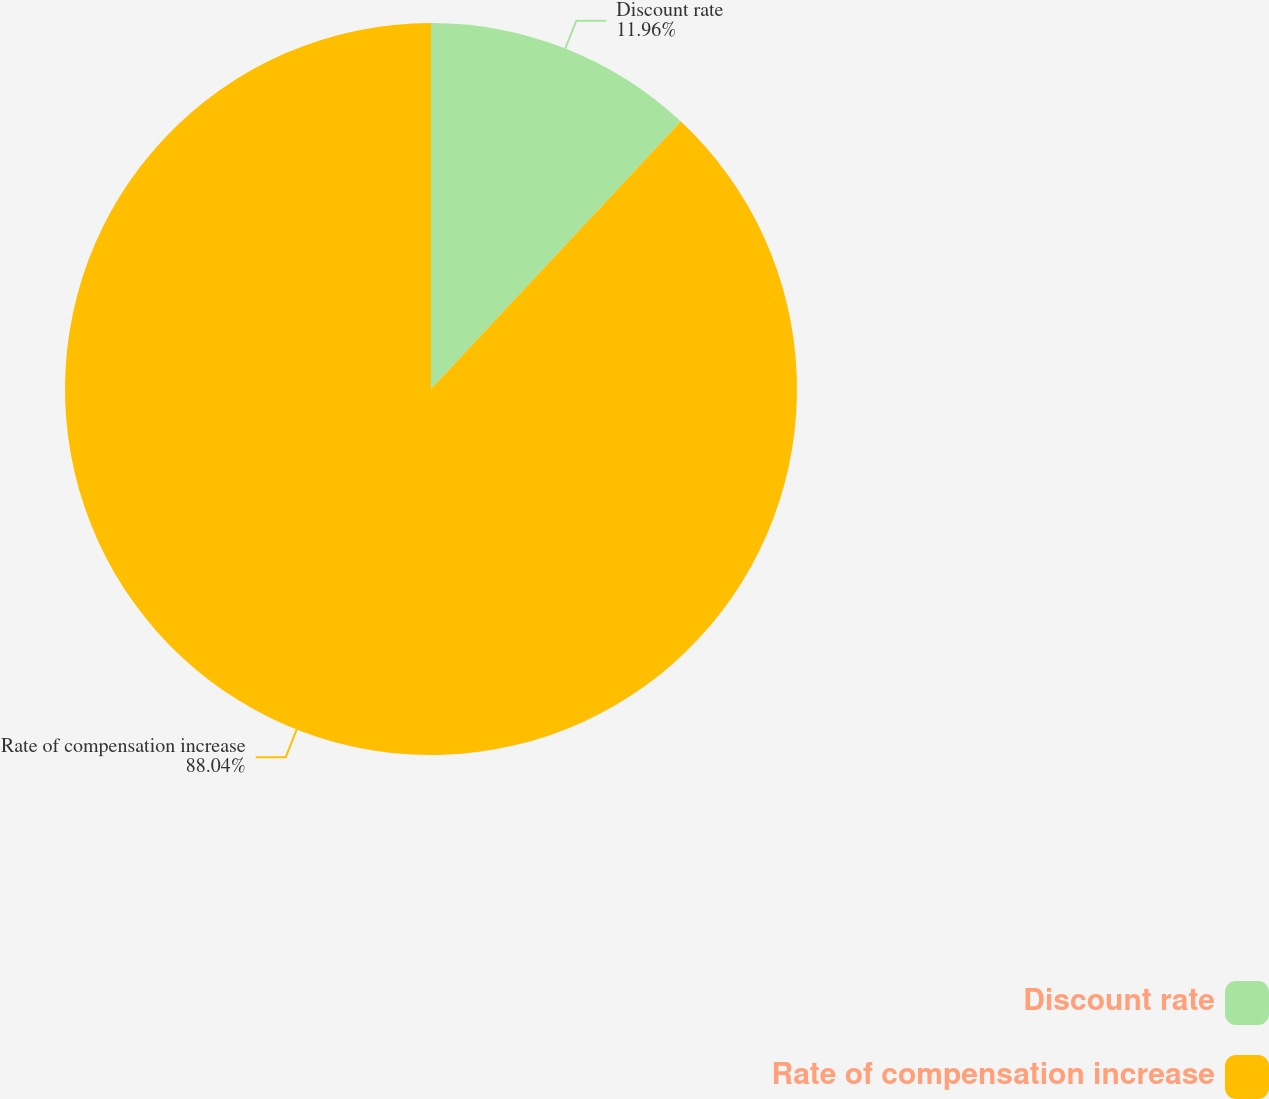Convert chart to OTSL. <chart><loc_0><loc_0><loc_500><loc_500><pie_chart><fcel>Discount rate<fcel>Rate of compensation increase<nl><fcel>11.96%<fcel>88.04%<nl></chart> 